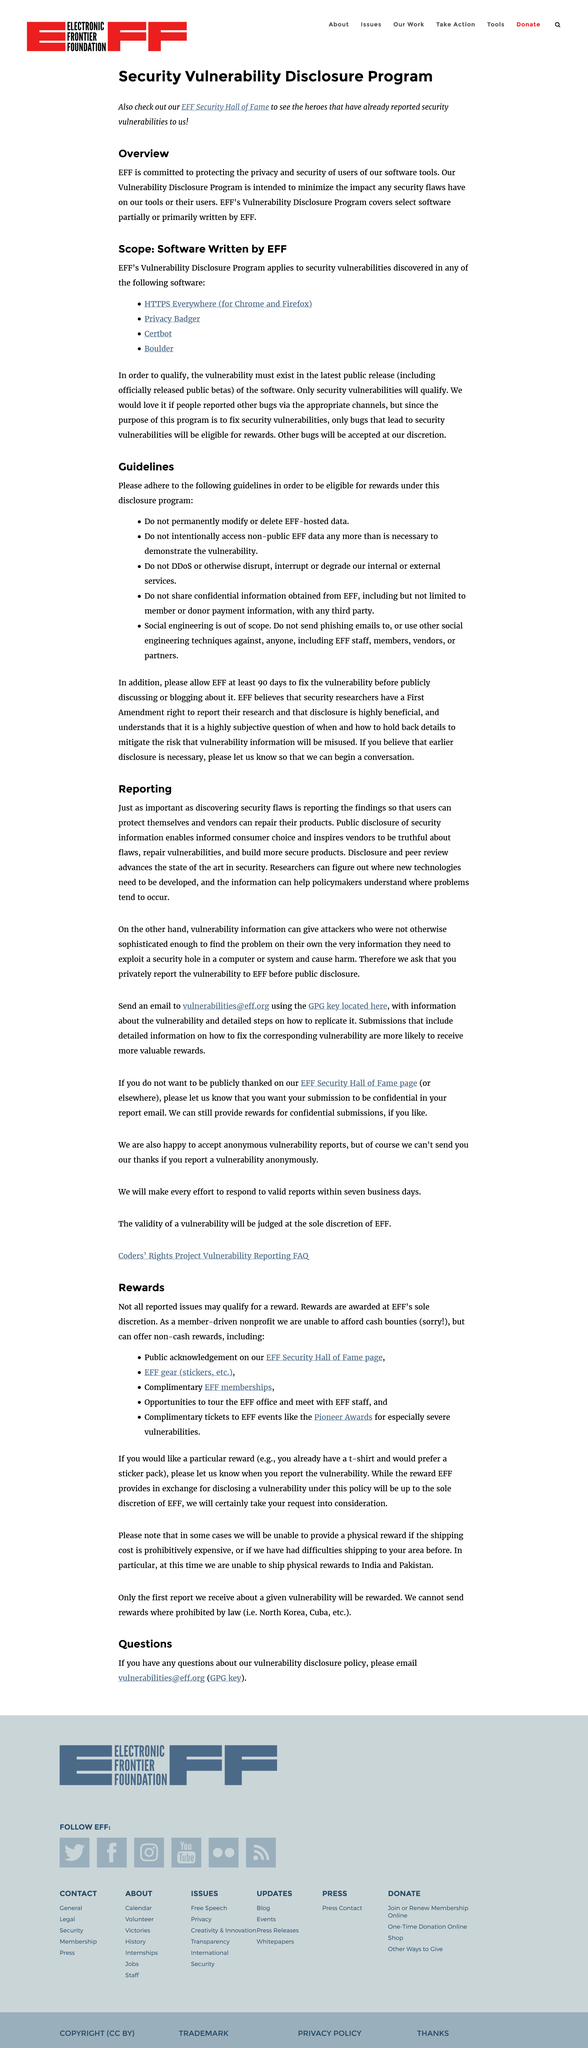Mention a couple of crucial points in this snapshot. The validity of a vulnerability will be judged solely at the discretion of EFF. It is not permissible to send phishing emails to other users. The entity that is committed to protecting the privacy and security of users of their software tools is the EFF. The latest public release of the software must contain the vulnerability. The EFF will accept anonymous vulnerability reports. 